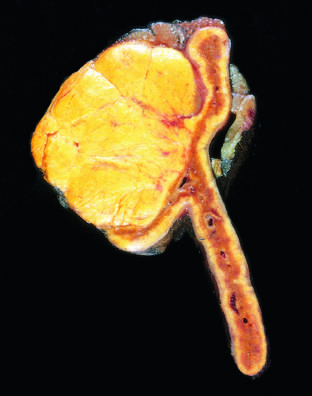what is distinguished from nodular hyperplasia by its solitary, circumscribed nature?
Answer the question using a single word or phrase. The adenoma 